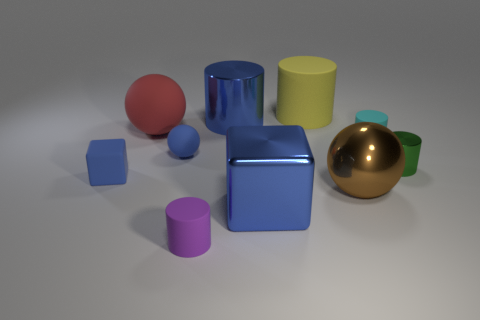Subtract 2 cylinders. How many cylinders are left? 3 Subtract all cyan matte cylinders. How many cylinders are left? 4 Subtract all cyan cylinders. How many cylinders are left? 4 Subtract all gray cylinders. Subtract all gray blocks. How many cylinders are left? 5 Subtract all spheres. How many objects are left? 7 Add 5 metallic cylinders. How many metallic cylinders are left? 7 Add 5 blue metal spheres. How many blue metal spheres exist? 5 Subtract 0 brown cylinders. How many objects are left? 10 Subtract all metal spheres. Subtract all metal cylinders. How many objects are left? 7 